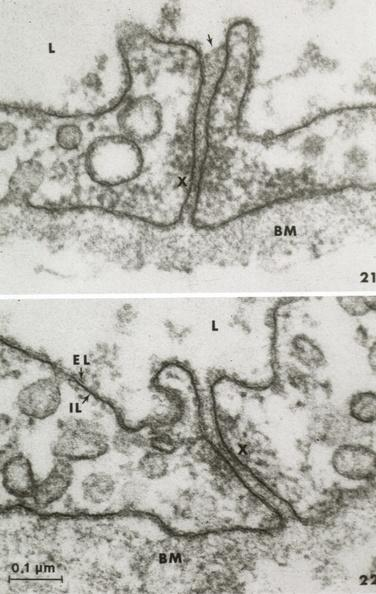s capillary present?
Answer the question using a single word or phrase. Yes 